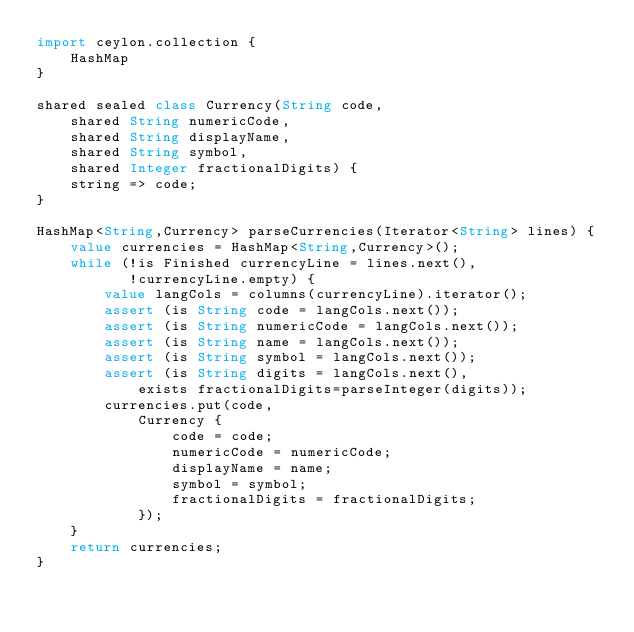Convert code to text. <code><loc_0><loc_0><loc_500><loc_500><_Ceylon_>import ceylon.collection {
    HashMap
}

shared sealed class Currency(String code, 
    shared String numericCode, 
    shared String displayName, 
    shared String symbol,
    shared Integer fractionalDigits) {
    string => code;
}

HashMap<String,Currency> parseCurrencies(Iterator<String> lines) {
    value currencies = HashMap<String,Currency>();
    while (!is Finished currencyLine = lines.next(), 
           !currencyLine.empty) {
        value langCols = columns(currencyLine).iterator();
        assert (is String code = langCols.next());
        assert (is String numericCode = langCols.next());
        assert (is String name = langCols.next());
        assert (is String symbol = langCols.next());
        assert (is String digits = langCols.next(), 
            exists fractionalDigits=parseInteger(digits));
        currencies.put(code,
            Currency {
                code = code;
                numericCode = numericCode;
                displayName = name;
                symbol = symbol;
                fractionalDigits = fractionalDigits;
            });
    }
    return currencies;
}
    </code> 